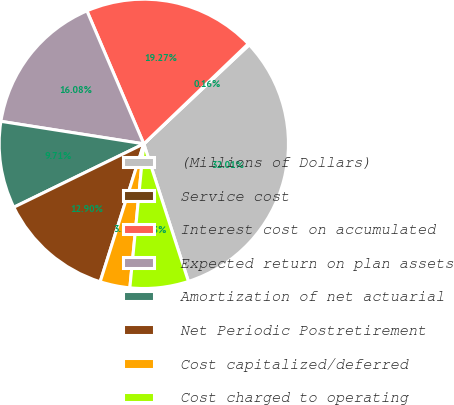<chart> <loc_0><loc_0><loc_500><loc_500><pie_chart><fcel>(Millions of Dollars)<fcel>Service cost<fcel>Interest cost on accumulated<fcel>Expected return on plan assets<fcel>Amortization of net actuarial<fcel>Net Periodic Postretirement<fcel>Cost capitalized/deferred<fcel>Cost charged to operating<nl><fcel>32.01%<fcel>0.16%<fcel>19.27%<fcel>16.08%<fcel>9.71%<fcel>12.9%<fcel>3.34%<fcel>6.53%<nl></chart> 